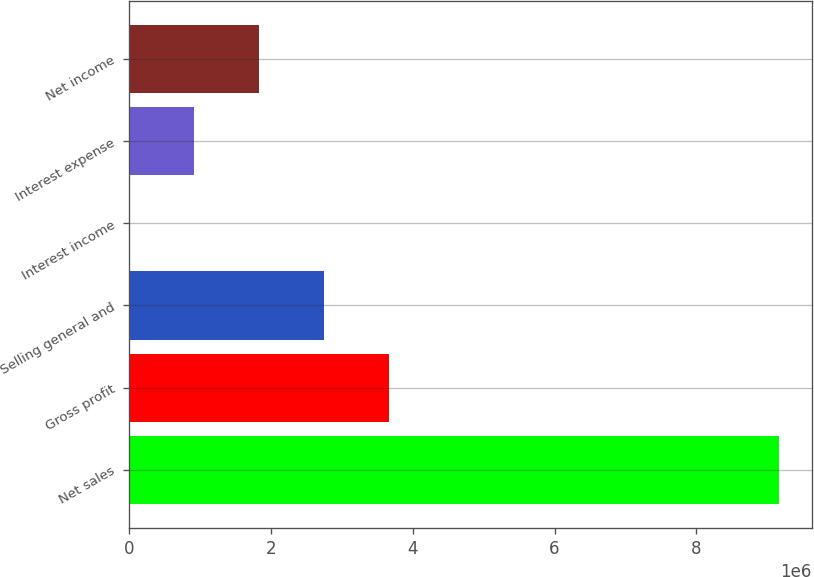<chart> <loc_0><loc_0><loc_500><loc_500><bar_chart><fcel>Net sales<fcel>Gross profit<fcel>Selling general and<fcel>Interest income<fcel>Interest expense<fcel>Net income<nl><fcel>9.16982e+06<fcel>3.67213e+06<fcel>2.75585e+06<fcel>7002<fcel>923284<fcel>1.83957e+06<nl></chart> 